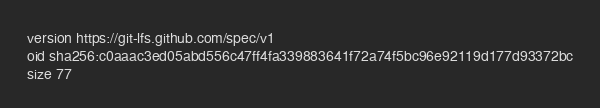Convert code to text. <code><loc_0><loc_0><loc_500><loc_500><_YAML_>version https://git-lfs.github.com/spec/v1
oid sha256:c0aaac3ed05abd556c47ff4fa339883641f72a74f5bc96e92119d177d93372bc
size 77
</code> 